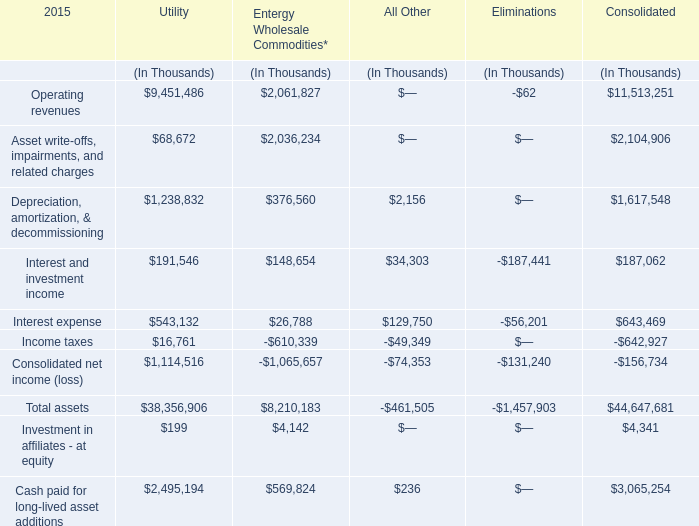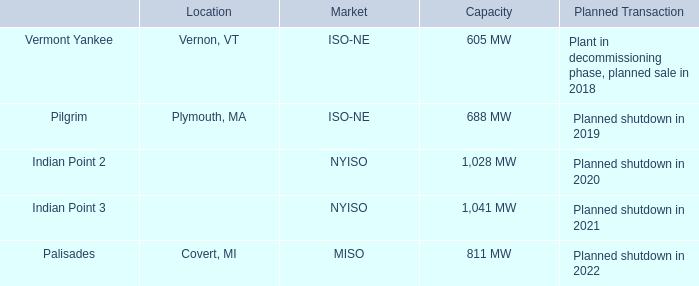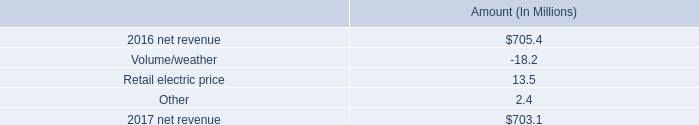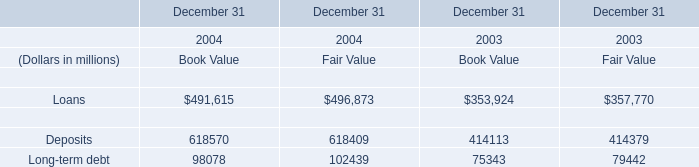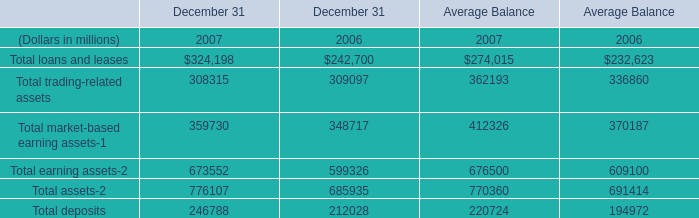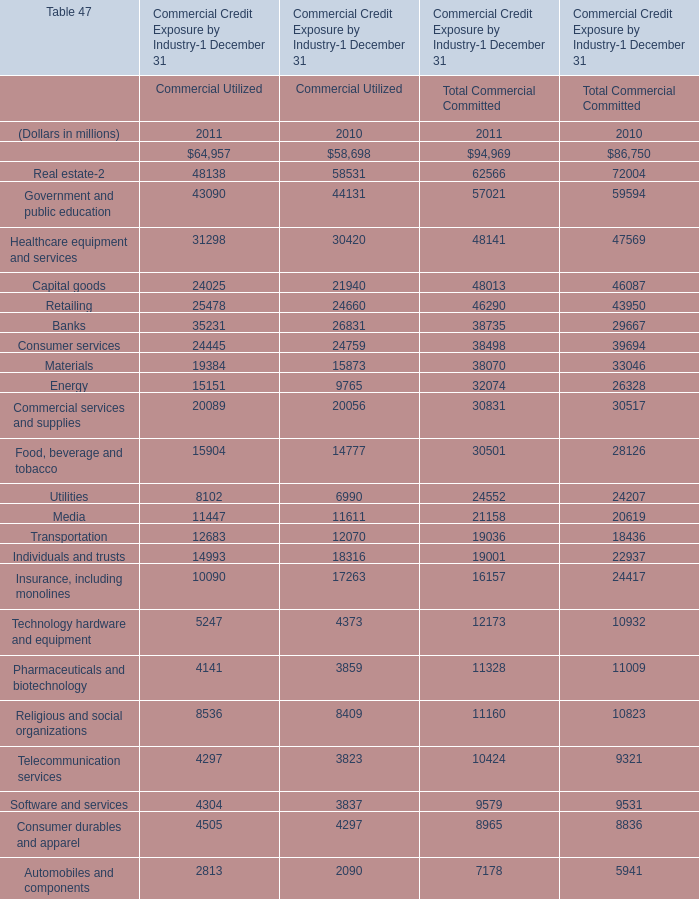What is the sum of Healthcare equipment and services of data 1 Commercial Utilized 2010, and Deposits Financial liabilities of December 31 2004 Book Value ? 
Computations: (30420.0 + 618570.0)
Answer: 648990.0. 